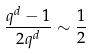Convert formula to latex. <formula><loc_0><loc_0><loc_500><loc_500>\frac { q ^ { d } - 1 } { 2 q ^ { d } } \sim \frac { 1 } { 2 }</formula> 